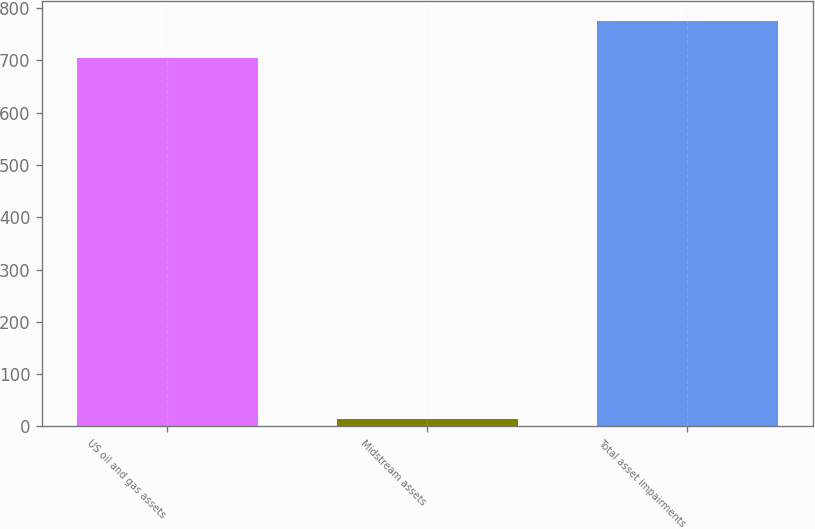Convert chart. <chart><loc_0><loc_0><loc_500><loc_500><bar_chart><fcel>US oil and gas assets<fcel>Midstream assets<fcel>Total asset impairments<nl><fcel>705<fcel>14<fcel>775.5<nl></chart> 